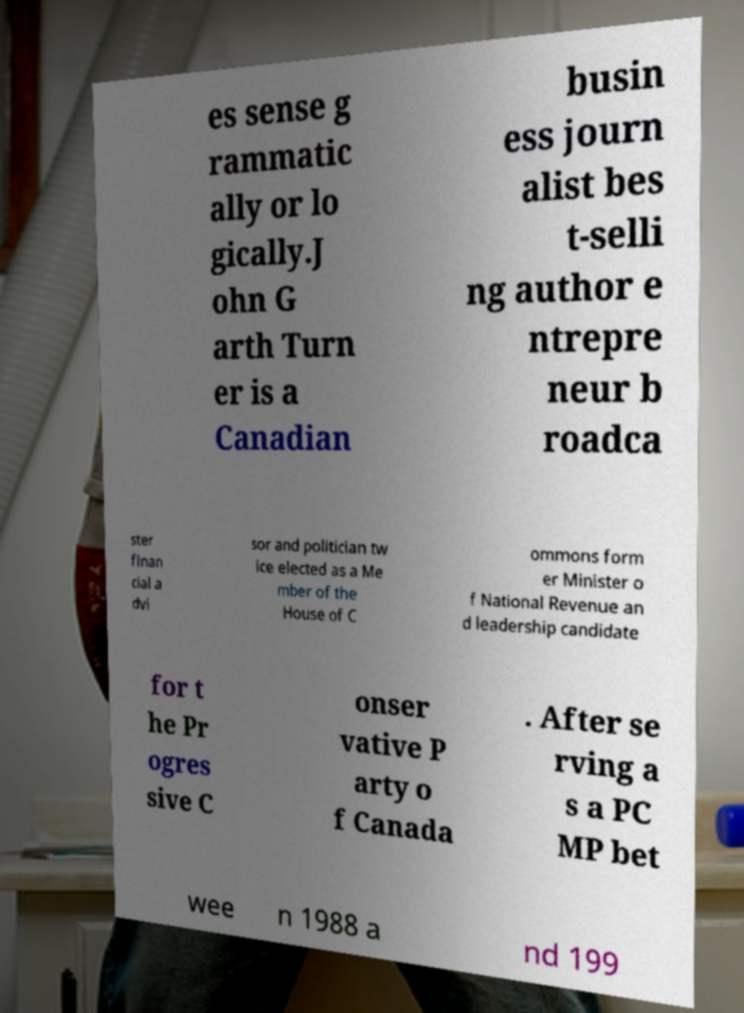Please identify and transcribe the text found in this image. es sense g rammatic ally or lo gically.J ohn G arth Turn er is a Canadian busin ess journ alist bes t-selli ng author e ntrepre neur b roadca ster finan cial a dvi sor and politician tw ice elected as a Me mber of the House of C ommons form er Minister o f National Revenue an d leadership candidate for t he Pr ogres sive C onser vative P arty o f Canada . After se rving a s a PC MP bet wee n 1988 a nd 199 